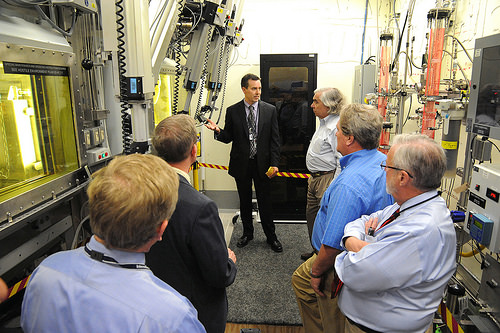<image>
Can you confirm if the man is in front of the door? Yes. The man is positioned in front of the door, appearing closer to the camera viewpoint. Is there a man to the left of the man? Yes. From this viewpoint, the man is positioned to the left side relative to the man. 